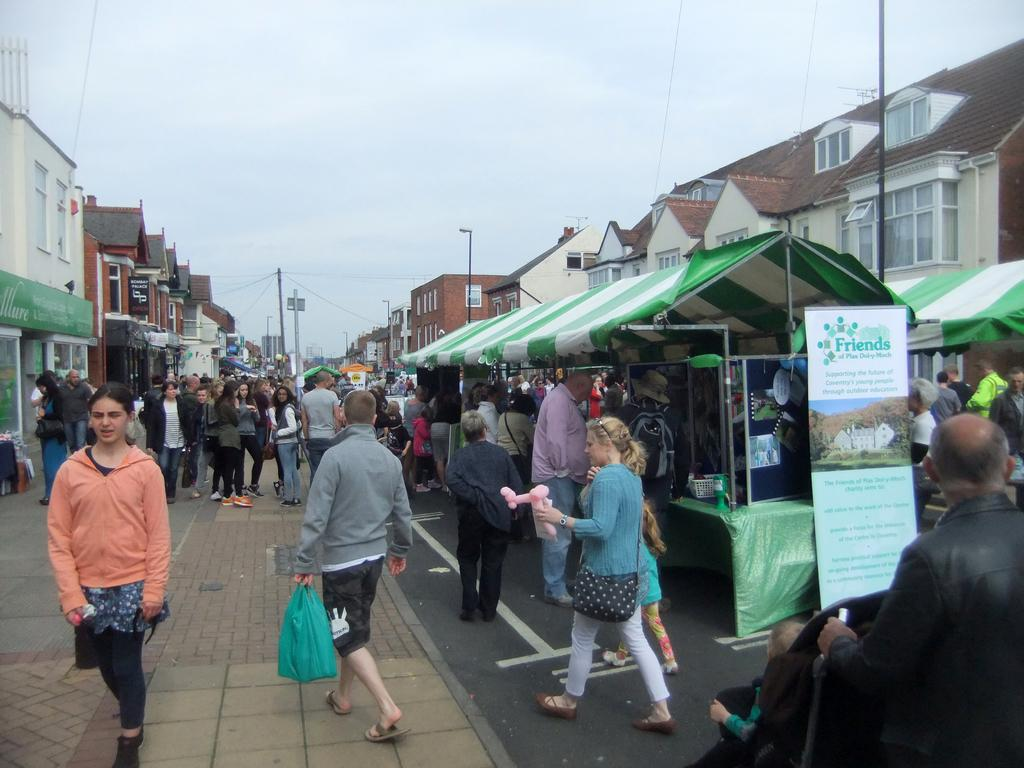What are the people in the image doing? There are people standing and walking in the image. What type of structures can be seen in the image? There are houses in the image. What is visible in the background of the image? The sky is visible in the image. What type of pie is being served on the apparatus in the image? There is no pie or apparatus present in the image; it only features people standing and walking, houses, and the sky. 